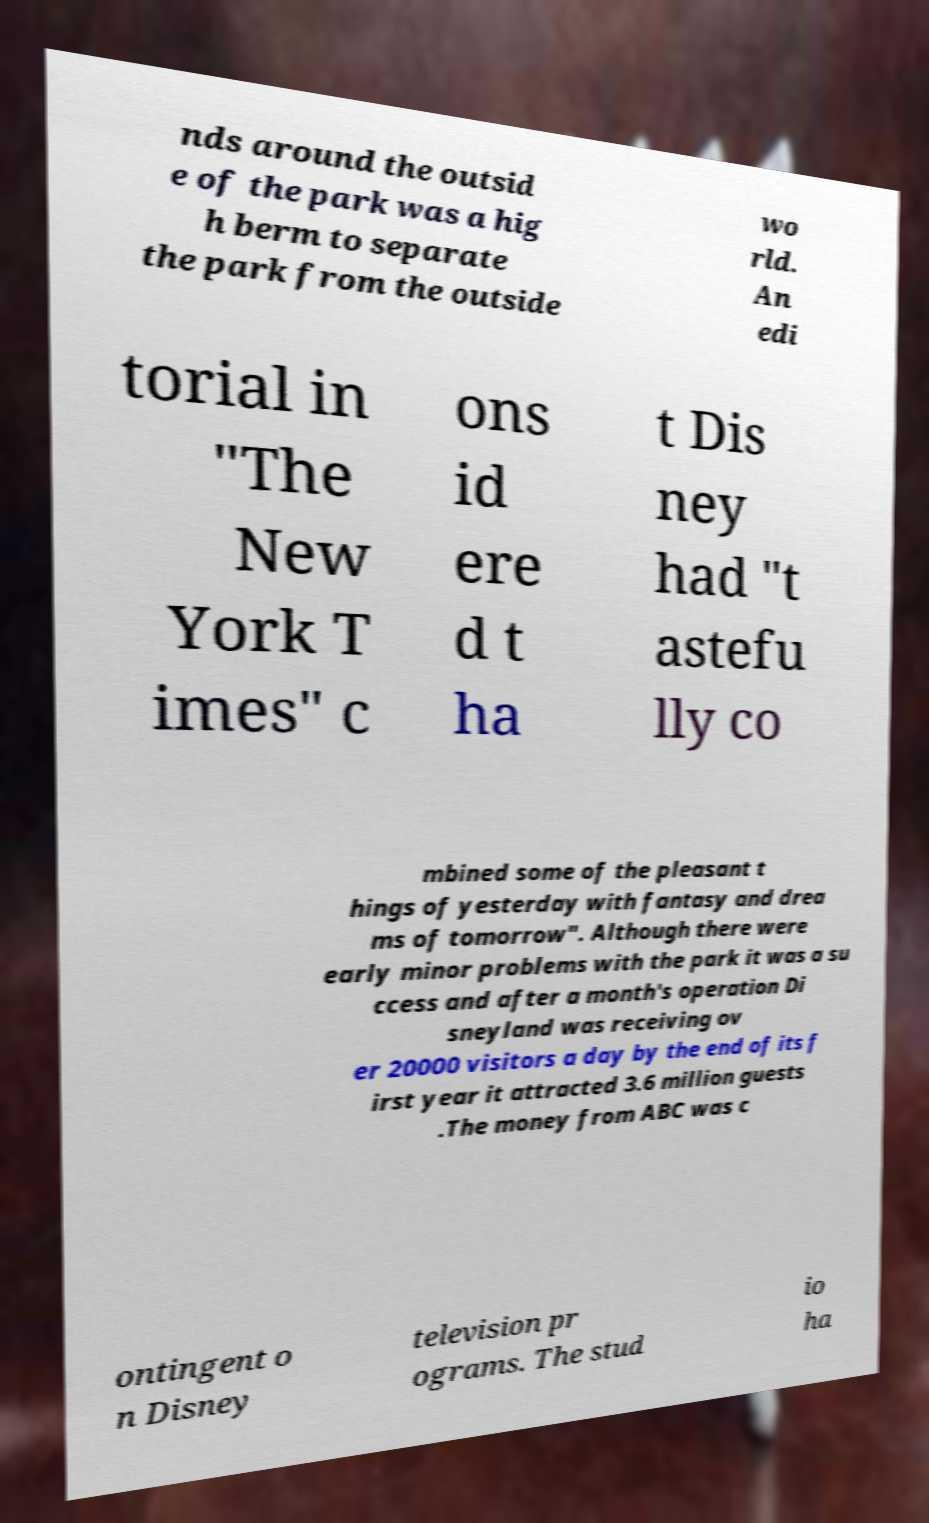For documentation purposes, I need the text within this image transcribed. Could you provide that? nds around the outsid e of the park was a hig h berm to separate the park from the outside wo rld. An edi torial in "The New York T imes" c ons id ere d t ha t Dis ney had "t astefu lly co mbined some of the pleasant t hings of yesterday with fantasy and drea ms of tomorrow". Although there were early minor problems with the park it was a su ccess and after a month's operation Di sneyland was receiving ov er 20000 visitors a day by the end of its f irst year it attracted 3.6 million guests .The money from ABC was c ontingent o n Disney television pr ograms. The stud io ha 